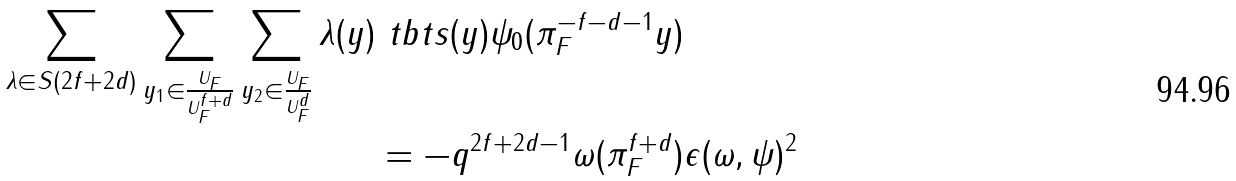Convert formula to latex. <formula><loc_0><loc_0><loc_500><loc_500>\sum _ { \lambda \in S ( 2 f + 2 d ) } \sum _ { y _ { 1 } \in \frac { U _ { F } } { U _ { F } ^ { f + d } } } \sum _ { y _ { 2 } \in \frac { U _ { F } } { U _ { F } ^ { d } } } \lambda ( y ) \ t b t s ( y ) \psi _ { 0 } ( \pi _ { F } ^ { - f - d - 1 } y ) & \\ = - q ^ { 2 f + 2 d - 1 } \omega ( \pi _ { F } ^ { f + d } ) & \epsilon ( \omega , \psi ) ^ { 2 }</formula> 